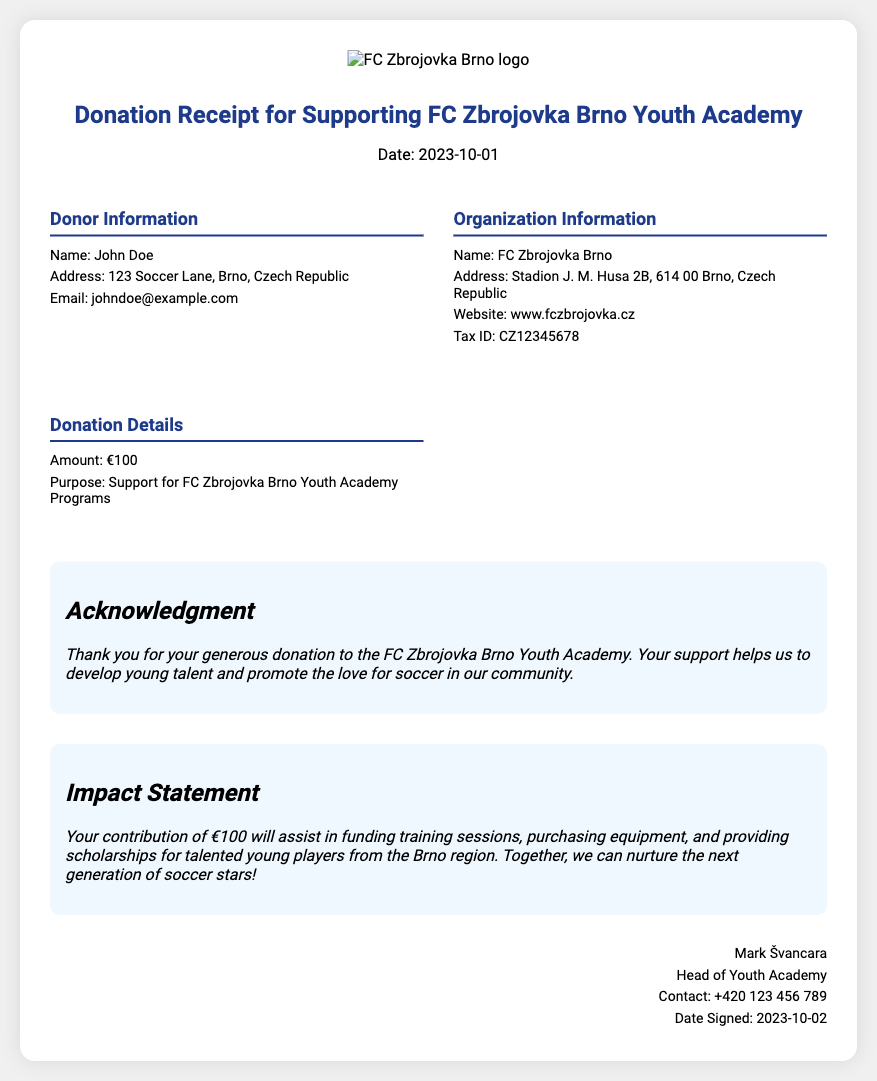What is the date of the donation receipt? The date mentioned in the receipt is when the donation was acknowledged, which is stated as "Date: 2023-10-01".
Answer: 2023-10-01 What is the donor's name? The document provides specific information about the donor, which is labeled under "Donor Information". The name listed is "John Doe".
Answer: John Doe What is the amount of the donation? The "Donation Details" section clearly states the amount contributed, which is "€100".
Answer: €100 Who is the head of the Youth Academy? The signature section of the document indicates the official who signed it, which is marked as "Mark Švancara".
Answer: Mark Švancara What is the purpose of the donation? The purpose of the donation is explicitly provided under the "Donation Details", stating it is for "Support for FC Zbrojovka Brno Youth Academy Programs".
Answer: Support for FC Zbrojovka Brno Youth Academy Programs What kind of support will the contribution assist with? The impact statement outlines specific areas that the contribution will support, including funding training sessions and purchasing equipment.
Answer: Funding training sessions, purchasing equipment, providing scholarships When was the receipt signed? The date when the receipt was signed can be found in the signature section, noted as "Date Signed: 2023-10-02".
Answer: 2023-10-02 What organization does the donor support? The document refers to the organization associated with the donation, which is "FC Zbrojovka Brno".
Answer: FC Zbrojovka Brno 